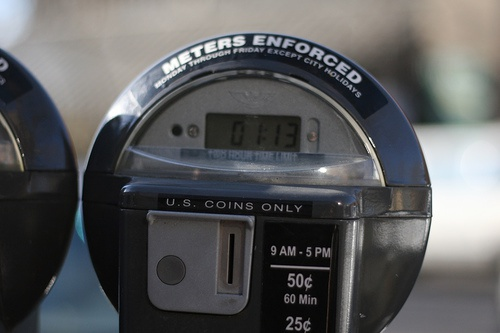Describe the objects in this image and their specific colors. I can see parking meter in lavender, black, gray, and darkgray tones, car in lavender, white, gray, darkgray, and black tones, and parking meter in lavender, black, gray, and blue tones in this image. 